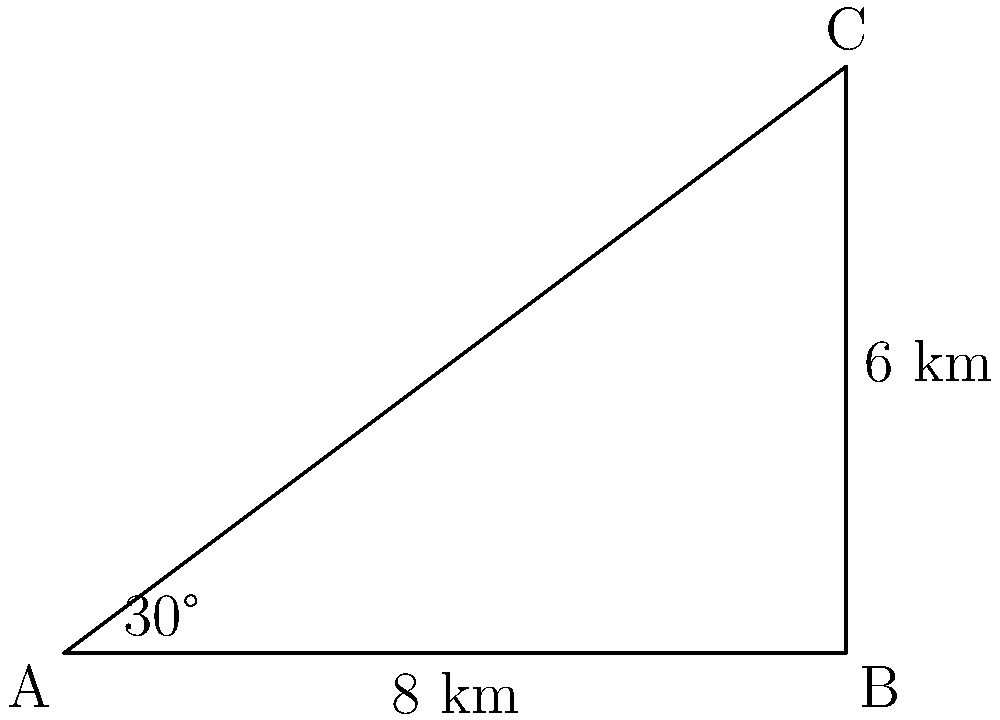A delivery truck needs to travel from point A to point C in a city with angled streets. The most direct route forms a right-angled triangle ABC, where AB is 8 km and BC is 6 km. The angle between the direct route (AC) and AB is 30°. Calculate the length of the most efficient route (AC) for the delivery truck. To solve this problem, we'll use the trigonometric ratio cosine in a right-angled triangle. Here's the step-by-step solution:

1) In a right-angled triangle, cosine of an angle is the ratio of the adjacent side to the hypotenuse.

2) In this case, we know:
   - The angle is 30°
   - The adjacent side (AB) is 8 km
   - We need to find the hypotenuse (AC)

3) The cosine formula is:
   $\cos \theta = \frac{\text{adjacent}}{\text{hypotenuse}}$

4) Substituting our known values:
   $\cos 30° = \frac{8}{\text{AC}}$

5) We know that $\cos 30° = \frac{\sqrt{3}}{2}$, so:
   $\frac{\sqrt{3}}{2} = \frac{8}{\text{AC}}$

6) Cross multiply:
   $\text{AC} \cdot \frac{\sqrt{3}}{2} = 8$

7) Solve for AC:
   $\text{AC} = \frac{8}{\frac{\sqrt{3}}{2}} = \frac{16}{\sqrt{3}} = \frac{16\sqrt{3}}{3}$

8) Simplify:
   $\text{AC} = \frac{16\sqrt{3}}{3} \approx 9.24$ km

Therefore, the most efficient route for the delivery truck is approximately 9.24 km long.
Answer: $\frac{16\sqrt{3}}{3}$ km or approximately 9.24 km 